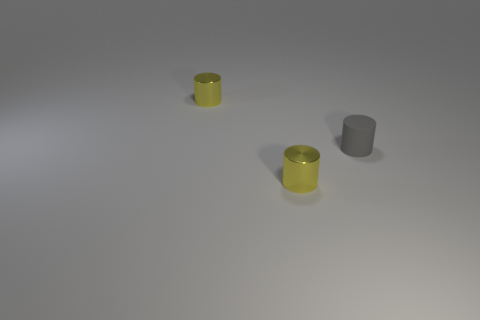Add 3 yellow metallic cylinders. How many objects exist? 6 Subtract all shiny objects. Subtract all small gray objects. How many objects are left? 0 Add 3 tiny gray matte cylinders. How many tiny gray matte cylinders are left? 4 Add 3 small gray things. How many small gray things exist? 4 Subtract 0 brown balls. How many objects are left? 3 